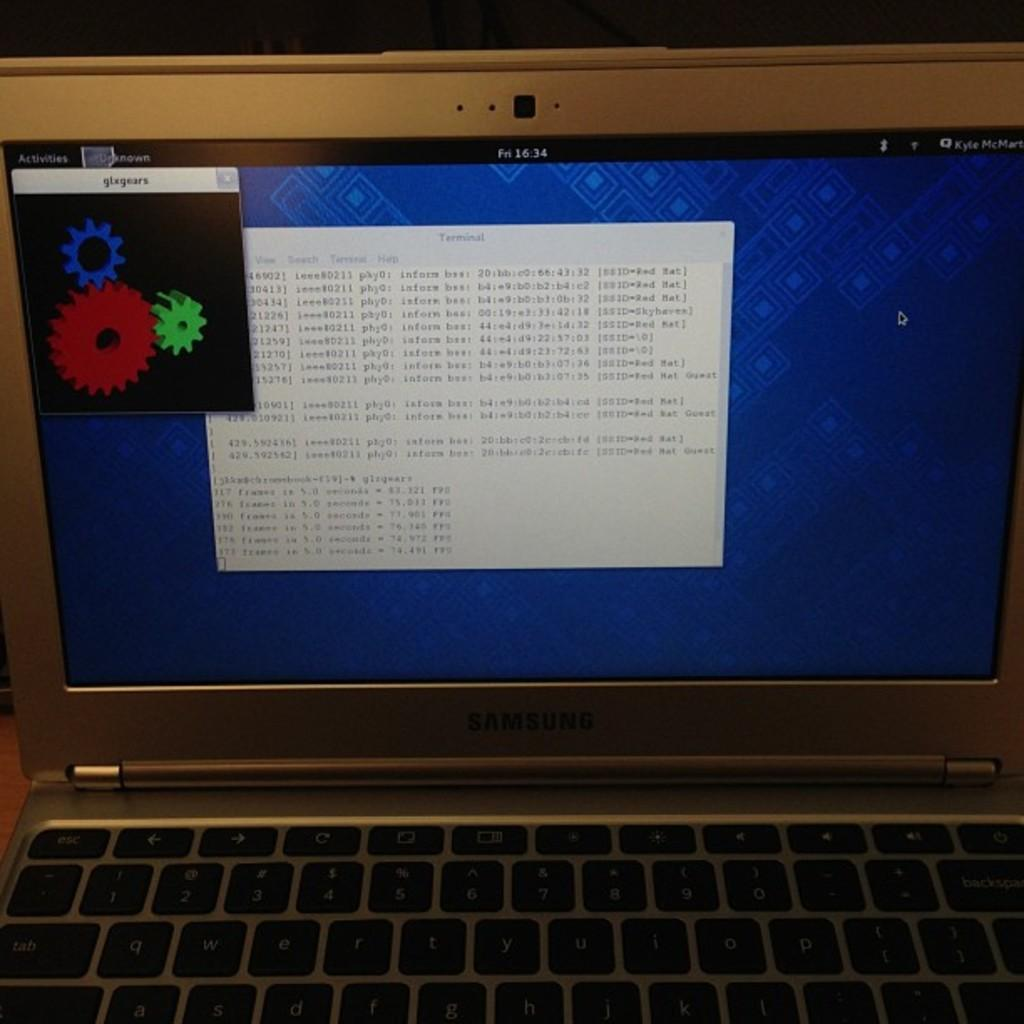<image>
Present a compact description of the photo's key features. The screen and top half of a Samsung laptop with a program called glxgears running. 